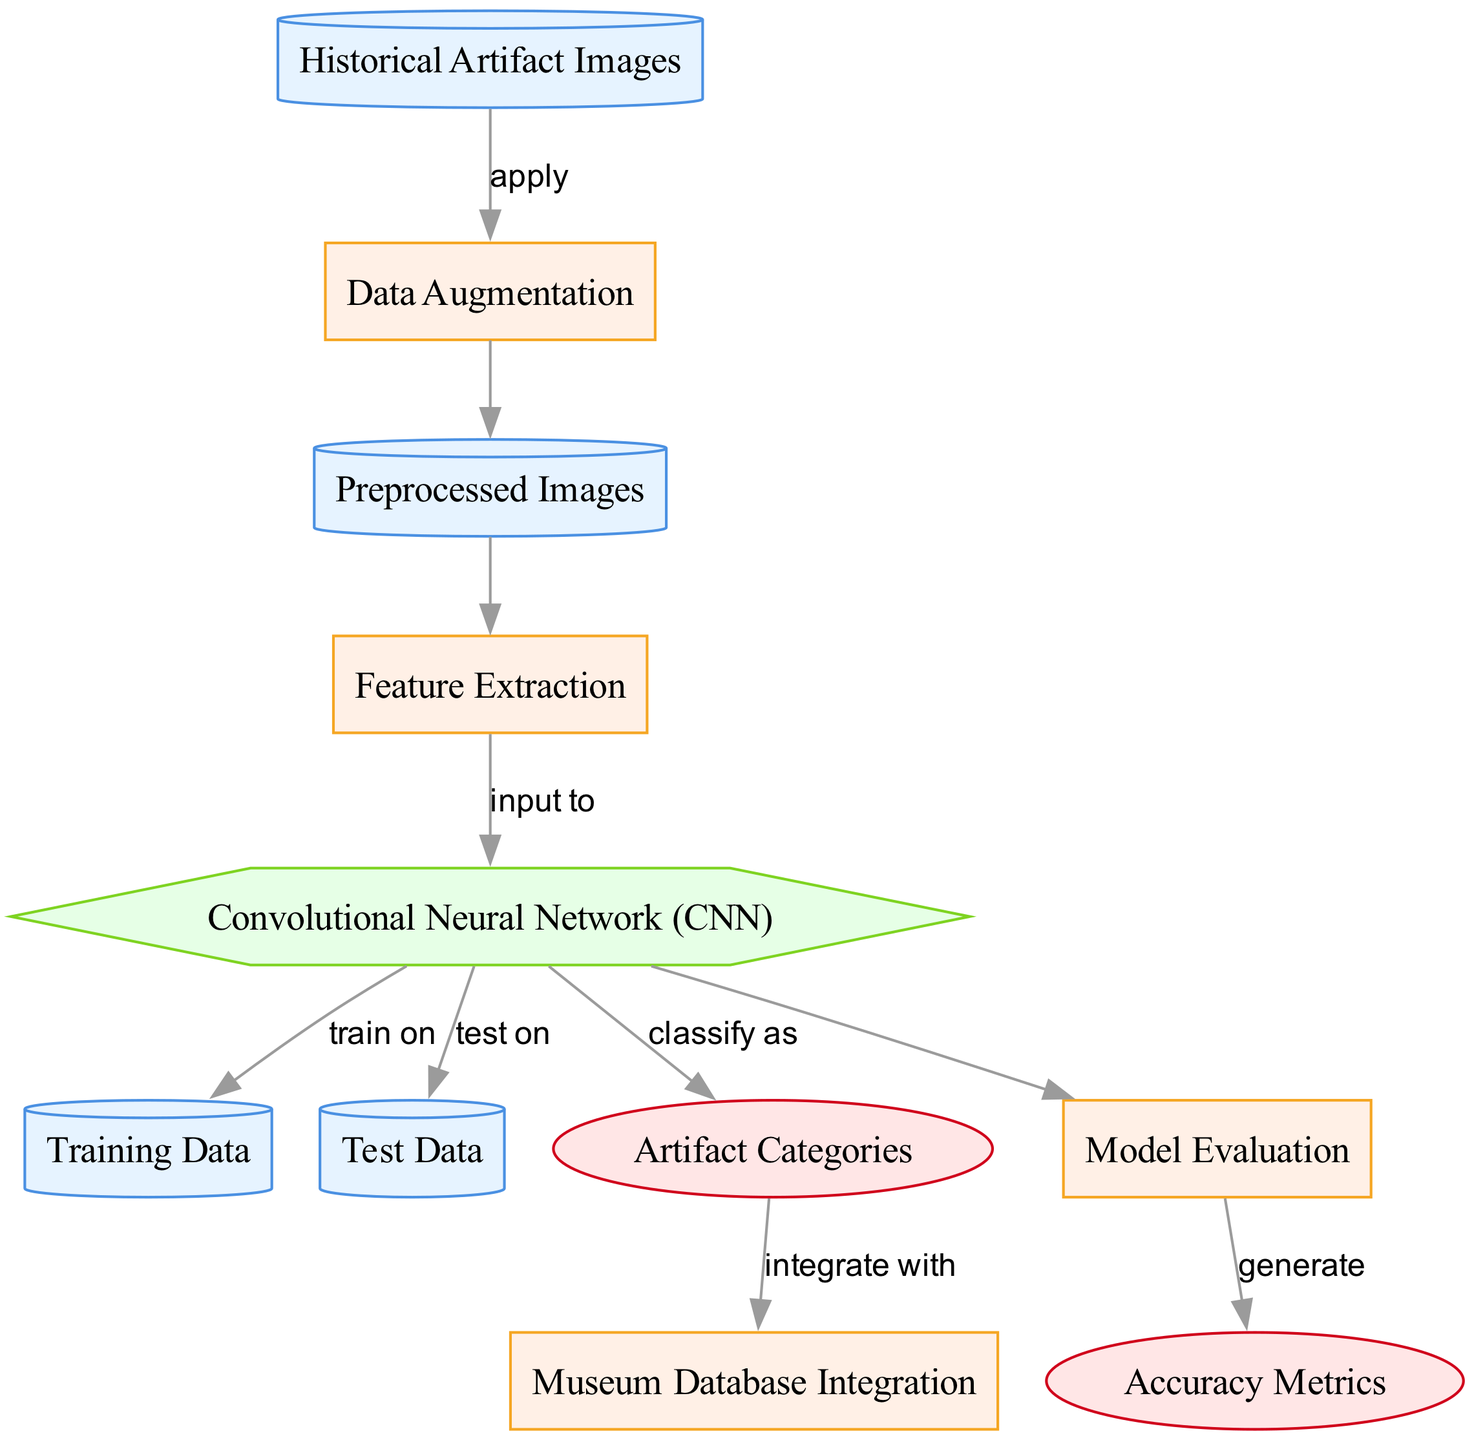What is the first node in the diagram? The first node is labeled "Historical Artifact Images," which represents the dataset input to the process.
Answer: Historical Artifact Images How many datasets are present in the diagram? There are four datasets in the diagram: "Historical Artifact Images," "Preprocessed Images," "Training Data," and "Test Data."
Answer: Four What process follows the data augmentation? The process that follows data augmentation is "Preprocessed Images," where the augmented data is prepared for further processing.
Answer: Preprocessed Images What is the final output of the model? The final output of the model is "Artifact Categories," which classifies the artifacts based on the learned features.
Answer: Artifact Categories Which process generates accuracy metrics? The "Model Evaluation" process generates the accuracy metrics after the model has been tested.
Answer: Model Evaluation What type of model is used in this diagram? The type of model used in this diagram is a "Convolutional Neural Network (CNN)," which is designed for image classification tasks.
Answer: Convolutional Neural Network (CNN) How do the artifact categories integrate with the museum database? The artifact categories integrate with the museum database through the "Museum Database Integration" process, ensuring the identification is cataloged accordingly.
Answer: Museum Database Integration What is the relationship between the CNN and the training data? The relationship is that the CNN is trained on the training data, allowing it to learn to classify the artifacts effectively.
Answer: train on What is the purpose of data augmentation in this diagram? The purpose of data augmentation is to increase the volume and diversity of the dataset by applying various transformations to the historical artifact images.
Answer: Increase dataset diversity 